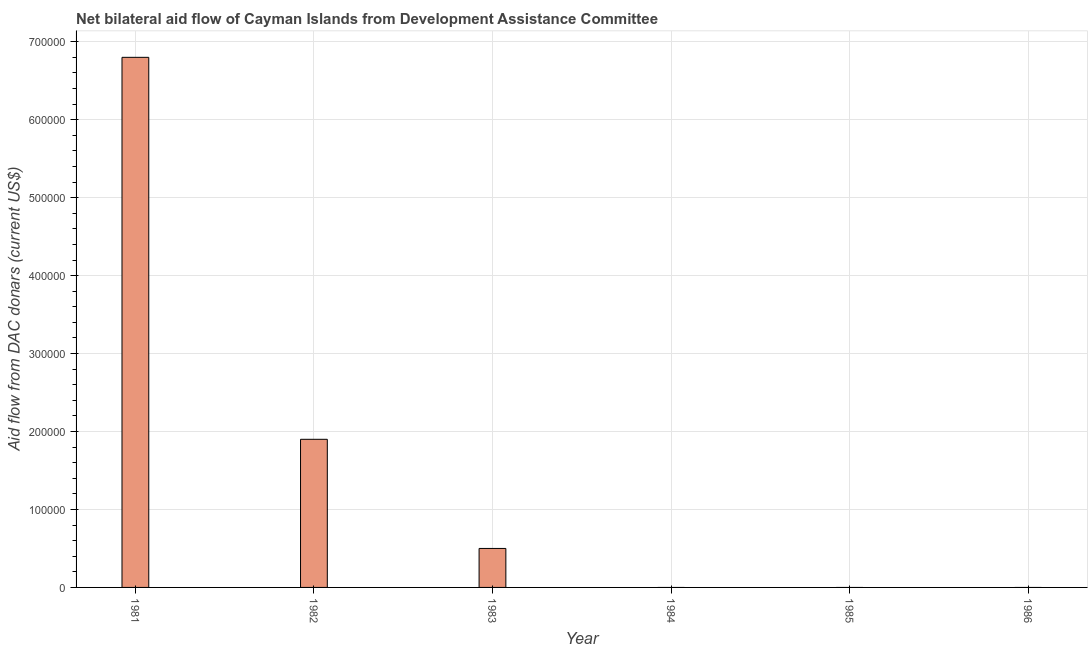Does the graph contain any zero values?
Keep it short and to the point. Yes. What is the title of the graph?
Make the answer very short. Net bilateral aid flow of Cayman Islands from Development Assistance Committee. What is the label or title of the Y-axis?
Make the answer very short. Aid flow from DAC donars (current US$). What is the net bilateral aid flows from dac donors in 1981?
Offer a terse response. 6.80e+05. Across all years, what is the maximum net bilateral aid flows from dac donors?
Keep it short and to the point. 6.80e+05. Across all years, what is the minimum net bilateral aid flows from dac donors?
Provide a succinct answer. 0. What is the sum of the net bilateral aid flows from dac donors?
Offer a very short reply. 9.20e+05. What is the average net bilateral aid flows from dac donors per year?
Provide a succinct answer. 1.53e+05. What is the median net bilateral aid flows from dac donors?
Make the answer very short. 2.50e+04. In how many years, is the net bilateral aid flows from dac donors greater than 680000 US$?
Give a very brief answer. 0. Is the difference between the net bilateral aid flows from dac donors in 1981 and 1982 greater than the difference between any two years?
Keep it short and to the point. No. What is the difference between the highest and the second highest net bilateral aid flows from dac donors?
Keep it short and to the point. 4.90e+05. What is the difference between the highest and the lowest net bilateral aid flows from dac donors?
Your answer should be very brief. 6.80e+05. Are all the bars in the graph horizontal?
Keep it short and to the point. No. How many years are there in the graph?
Ensure brevity in your answer.  6. What is the difference between two consecutive major ticks on the Y-axis?
Your answer should be very brief. 1.00e+05. What is the Aid flow from DAC donars (current US$) of 1981?
Your response must be concise. 6.80e+05. What is the Aid flow from DAC donars (current US$) of 1984?
Provide a short and direct response. 0. What is the difference between the Aid flow from DAC donars (current US$) in 1981 and 1982?
Make the answer very short. 4.90e+05. What is the difference between the Aid flow from DAC donars (current US$) in 1981 and 1983?
Give a very brief answer. 6.30e+05. What is the difference between the Aid flow from DAC donars (current US$) in 1982 and 1983?
Ensure brevity in your answer.  1.40e+05. What is the ratio of the Aid flow from DAC donars (current US$) in 1981 to that in 1982?
Your answer should be compact. 3.58. What is the ratio of the Aid flow from DAC donars (current US$) in 1981 to that in 1983?
Ensure brevity in your answer.  13.6. What is the ratio of the Aid flow from DAC donars (current US$) in 1982 to that in 1983?
Your response must be concise. 3.8. 